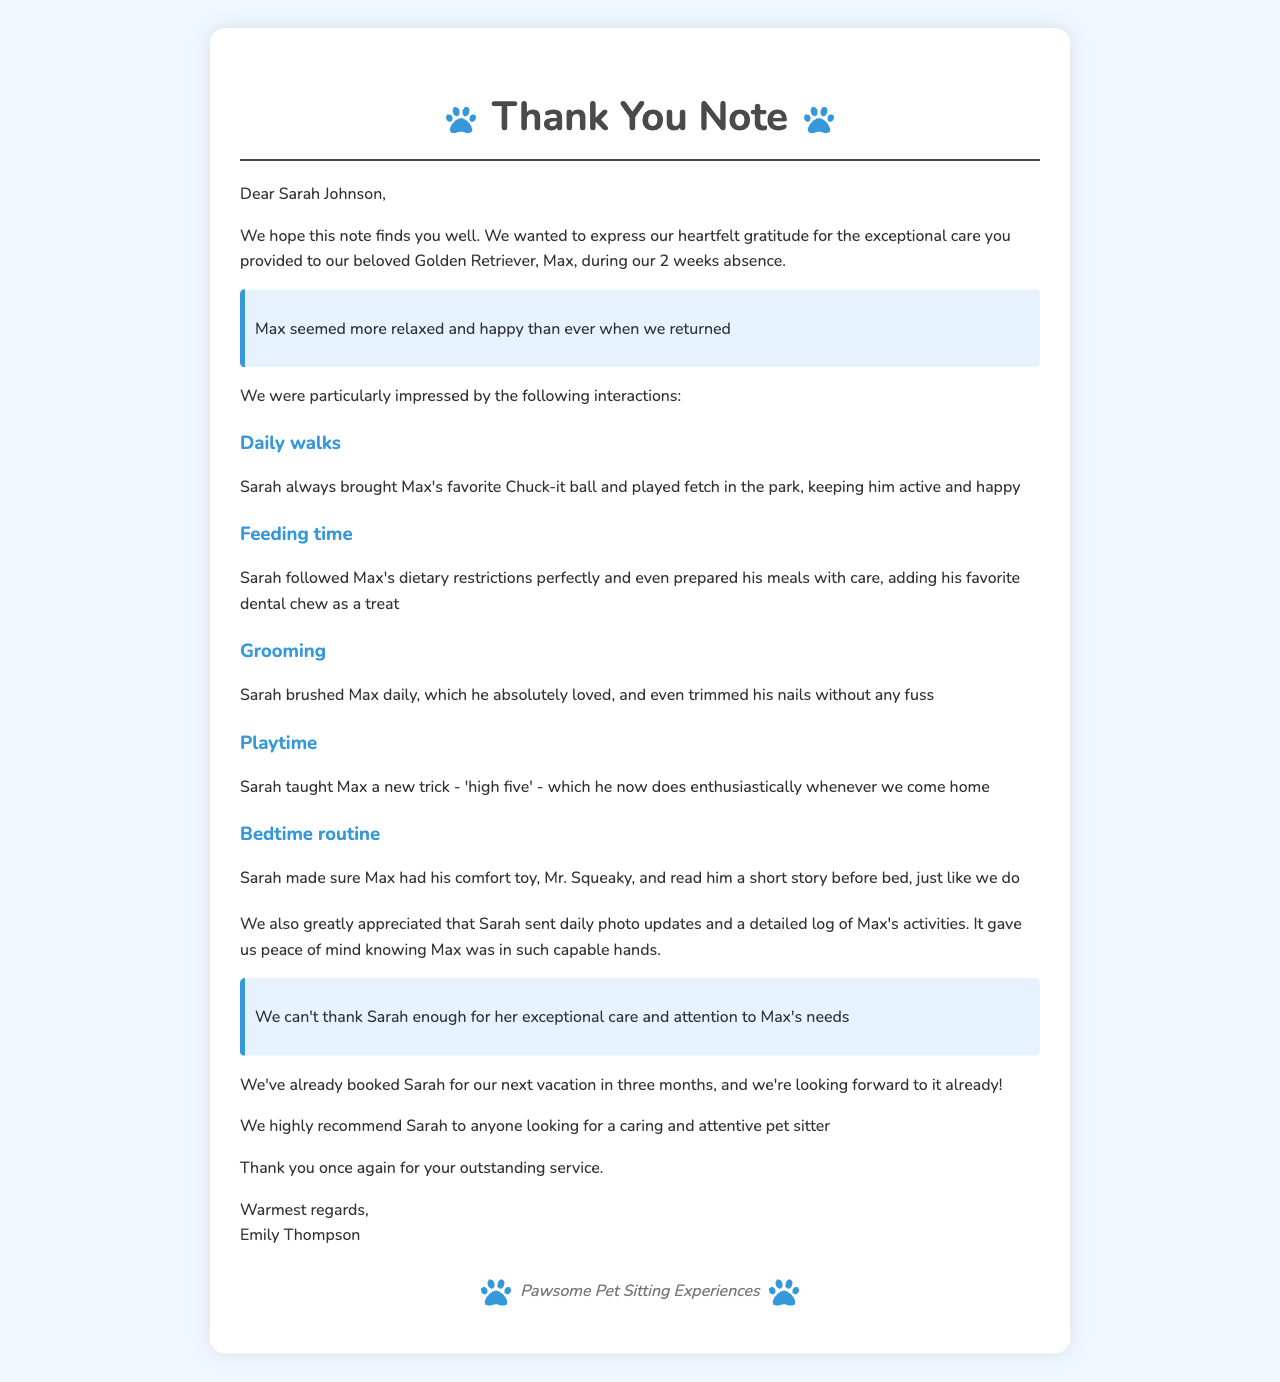What is the name of the client? The client's name is mentioned in the letter as the person thanking the pet sitter.
Answer: Emily Thompson What breed is the dog? The breed of the dog is specified in the document to describe the pet.
Answer: Golden Retriever How long was the pet sitting duration? The duration of the pet sitting service is noted in the document, indicating the time frame.
Answer: 2 weeks What trick did Sarah teach Max? The letter highlights a specific trick that was taught to the dog during the pet sitting period.
Answer: high five What additional service did Sarah provide? The document mentions an extra service that adds to the satisfaction of the client.
Answer: daily photo updates What was Emily's overall impression of Max after the sitting? This reflects the client's feeling about Max's state upon their return, showing satisfaction with the service.
Answer: more relaxed and happy How did Sarah ensure Max's dietary needs were met? The letter provides details on how the pet sitter followed the dog's dietary restrictions.
Answer: followed Max's dietary restrictions perfectly When is the next scheduled pet sitting? The document specifies when the client plans to use the pet sitter's services again.
Answer: in three months What is Emily's recommendation regarding Sarah? The document includes a recommendation that indicates the trust the client has in the pet sitter's abilities.
Answer: highly recommend Sarah 